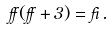Convert formula to latex. <formula><loc_0><loc_0><loc_500><loc_500>\alpha ( \alpha + 3 ) = \beta \, .</formula> 